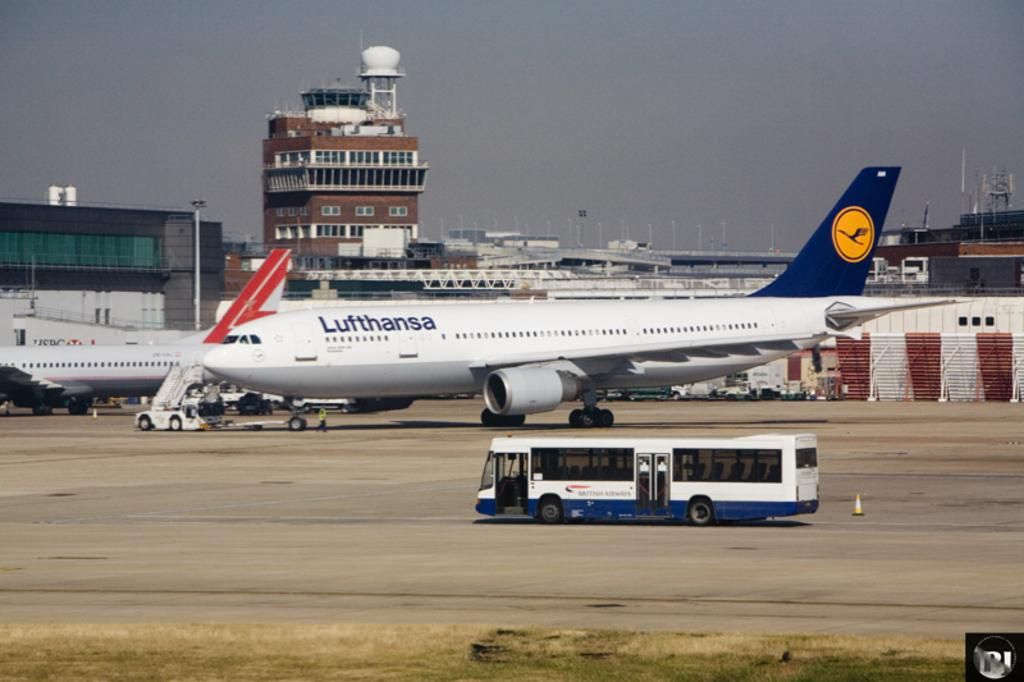What is the main subject of the image? The main subject of the image is a bus. What else can be seen in the image besides the bus? There are airplanes on a runway, sheds, buildings, and the sky visible in the background of the image. What type of songs can be heard coming from the bell in the image? There is no bell present in the image, so it's not possible to determine what, if any, songs might be heard. 